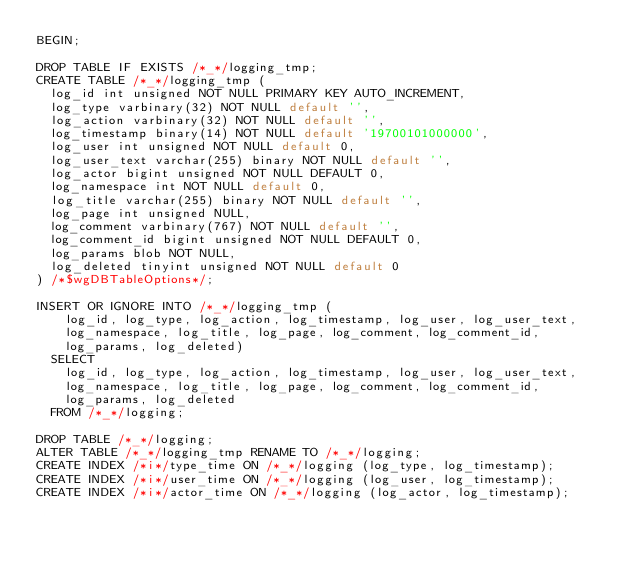Convert code to text. <code><loc_0><loc_0><loc_500><loc_500><_SQL_>BEGIN;

DROP TABLE IF EXISTS /*_*/logging_tmp;
CREATE TABLE /*_*/logging_tmp (
  log_id int unsigned NOT NULL PRIMARY KEY AUTO_INCREMENT,
  log_type varbinary(32) NOT NULL default '',
  log_action varbinary(32) NOT NULL default '',
  log_timestamp binary(14) NOT NULL default '19700101000000',
  log_user int unsigned NOT NULL default 0,
  log_user_text varchar(255) binary NOT NULL default '',
  log_actor bigint unsigned NOT NULL DEFAULT 0,
  log_namespace int NOT NULL default 0,
  log_title varchar(255) binary NOT NULL default '',
  log_page int unsigned NULL,
  log_comment varbinary(767) NOT NULL default '',
  log_comment_id bigint unsigned NOT NULL DEFAULT 0,
  log_params blob NOT NULL,
  log_deleted tinyint unsigned NOT NULL default 0
) /*$wgDBTableOptions*/;

INSERT OR IGNORE INTO /*_*/logging_tmp (
	log_id, log_type, log_action, log_timestamp, log_user, log_user_text,
	log_namespace, log_title, log_page, log_comment, log_comment_id,
	log_params, log_deleted)
  SELECT
	log_id, log_type, log_action, log_timestamp, log_user, log_user_text,
	log_namespace, log_title, log_page, log_comment, log_comment_id,
	log_params, log_deleted
  FROM /*_*/logging;

DROP TABLE /*_*/logging;
ALTER TABLE /*_*/logging_tmp RENAME TO /*_*/logging;
CREATE INDEX /*i*/type_time ON /*_*/logging (log_type, log_timestamp);
CREATE INDEX /*i*/user_time ON /*_*/logging (log_user, log_timestamp);
CREATE INDEX /*i*/actor_time ON /*_*/logging (log_actor, log_timestamp);</code> 